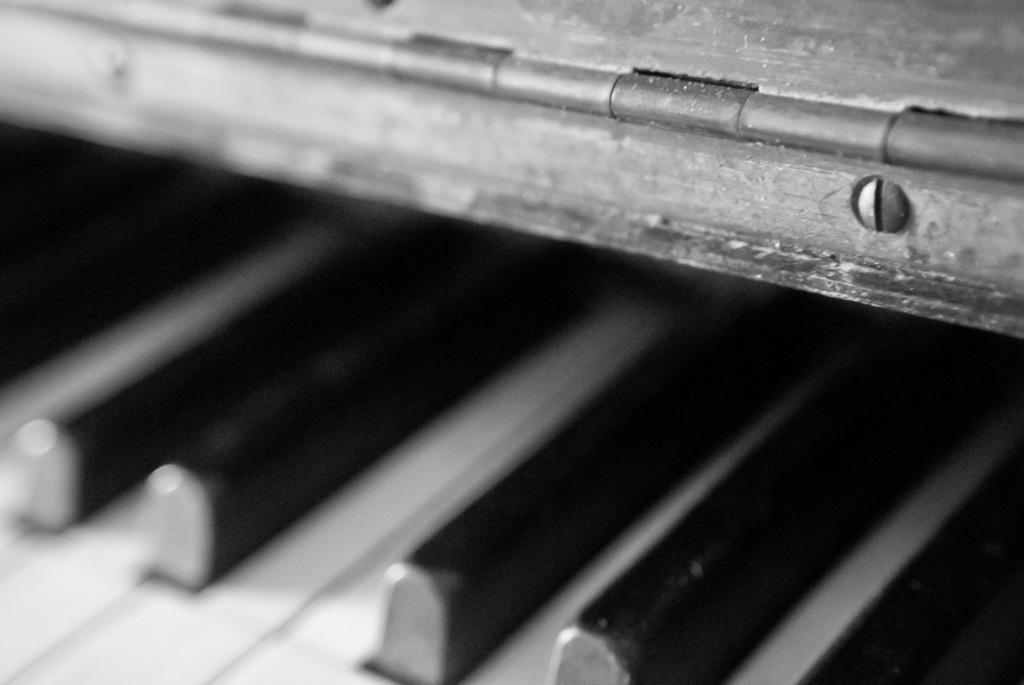What type of instrument is visible in the image? There is a musical keyboard in the image. What might someone be doing with the musical keyboard? Someone might be playing the musical keyboard or practicing their skills. Can you describe the design or appearance of the musical keyboard? The image only shows the musical keyboard, so it's not possible to describe its design or appearance in detail. How many chickens are present in the image? There are no chickens present in the image; it only features a musical keyboard. 